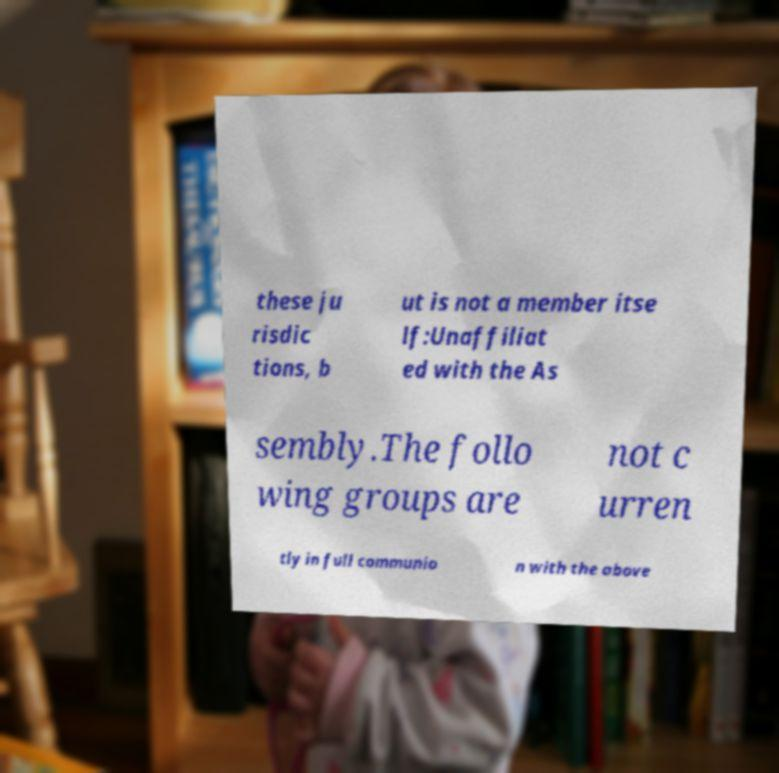There's text embedded in this image that I need extracted. Can you transcribe it verbatim? these ju risdic tions, b ut is not a member itse lf:Unaffiliat ed with the As sembly.The follo wing groups are not c urren tly in full communio n with the above 